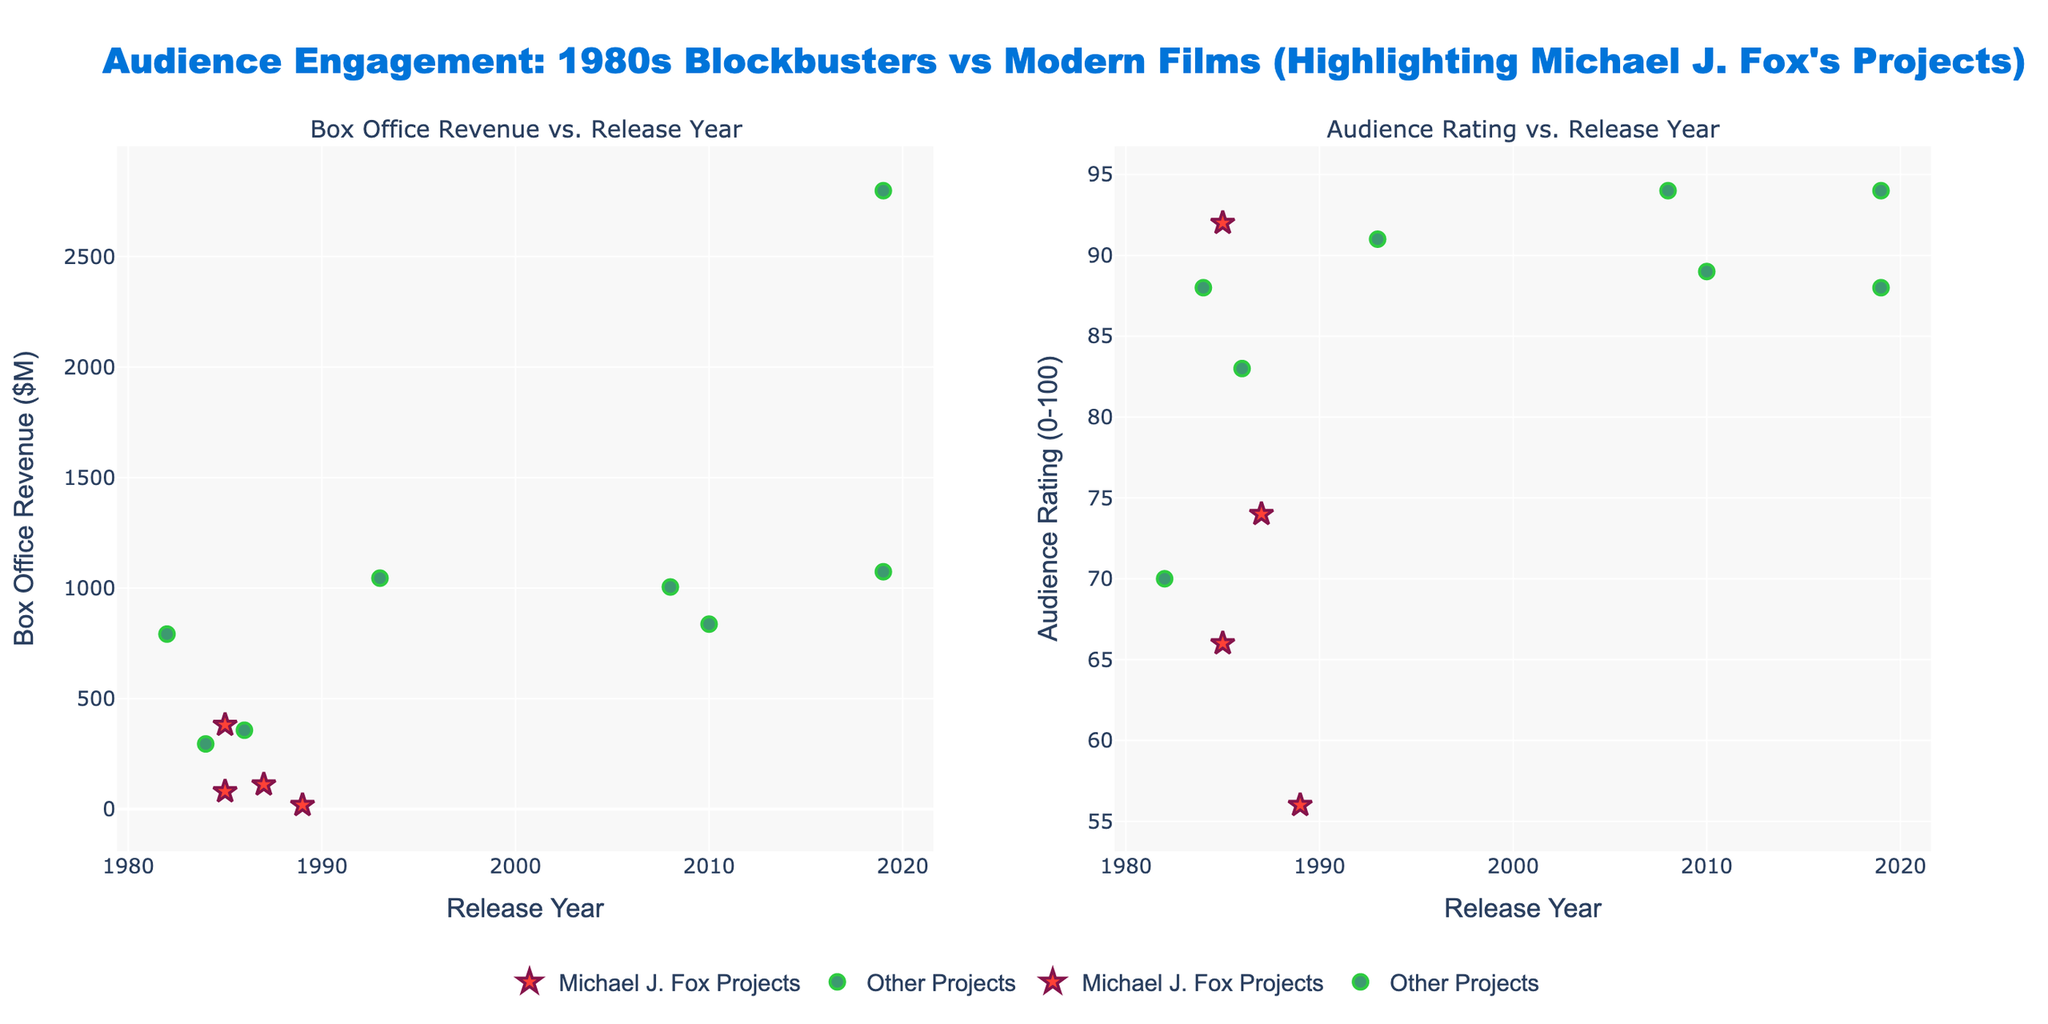What is the title of the subplot on the left? The title of the subplot on the left can be read directly from the figure. It is presented above the graph to indicate what the plot represents.
Answer: Box Office Revenue vs. Release Year How many Michael J. Fox projects are featured in the plots? By observing the markers represented as stars in both subplots, one can count the number of data points corresponding to Michael J. Fox projects.
Answer: 4 What project has the highest audience rating among Michael J. Fox's films? In the second subplot (Audience Rating vs. Release Year), the Michael J. Fox projects' data points can be identified and compared to find the highest y-value (rating).
Answer: Back to the Future Which film released in the 2010s has the highest box office revenue? In the first subplot (Box Office Revenue vs. Release Year), locate the data points representing the 2010s and compare their y-values (revenue).
Answer: Avengers: Endgame What is the average audience rating for Michael J. Fox's projects? Identify the y-values (ratings) of the stars (representing Michael J. Fox projects) in the second subplot, sum these values, and then divide by the number of projects. Ratings: 92, 66, 74, 56. Sum = 288, Number of projects = 4, Average: 288/4 = 72
Answer: 72 Which project has the lowest box office revenue among Michael J. Fox's films, and what is its revenue? In the first subplot, find the Michael J. Fox data points and identify the one with the lowest y-value (revenue).
Answer: Casualties of War, $18M Are there any Michael J. Fox projects that outperform both other projects in revenue and audience rating? Visually assess Michael J. Fox’s projects in both subplots to see if any of the stars are positioned above all the other projects’ markers in terms of y-values in both plots.
Answer: No Compare the average box office revenue of Blockbusters from the 1980s to those of modern films (2000s and later). First, calculate the average box office revenue of films released in the 1980s and then for films from the 2000s onwards. Compare these averages: 1980s: (381+80+111+18+295+357+792)/7 = 290.57, Modern: (2798+1074+837+1005)/4 = 1778.5
Answer: 1980s: $290.57M, Modern: $1778.5M 